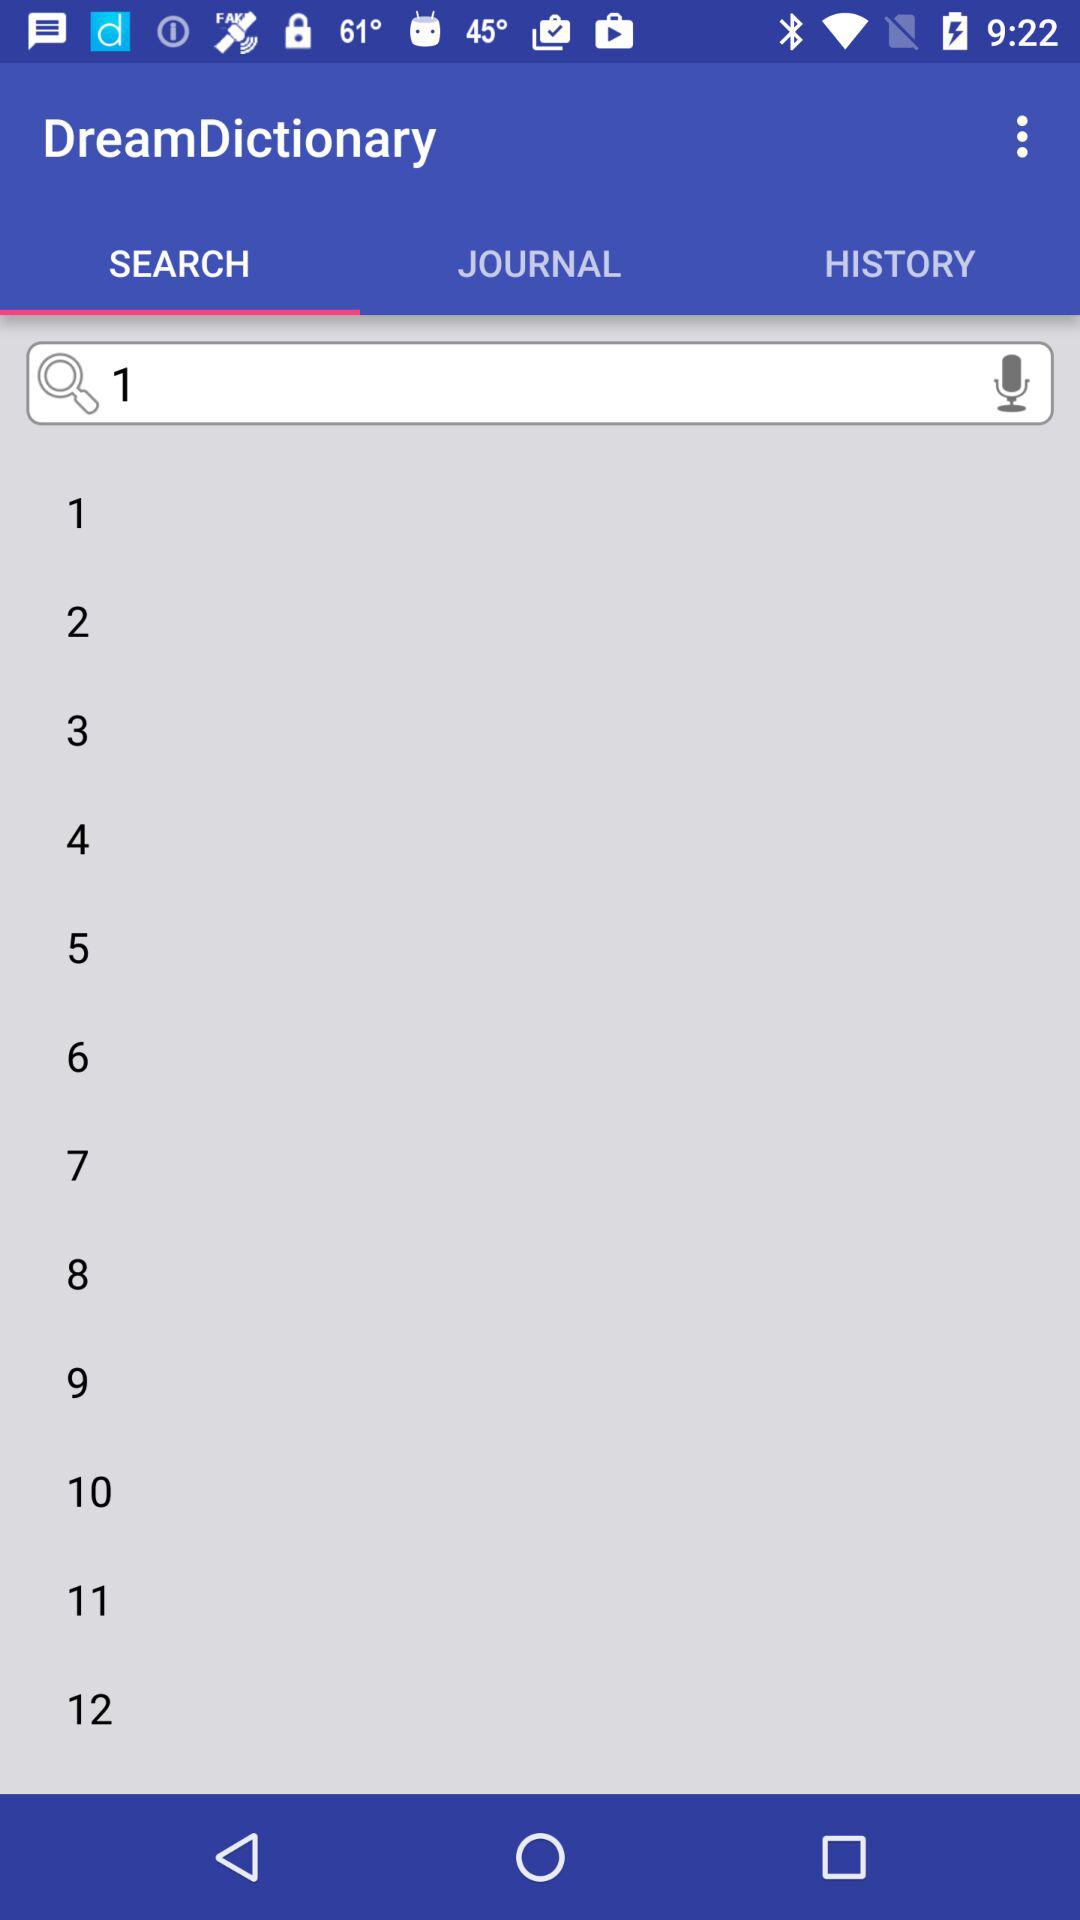What is the application name? The application name is "DreamDictionary". 